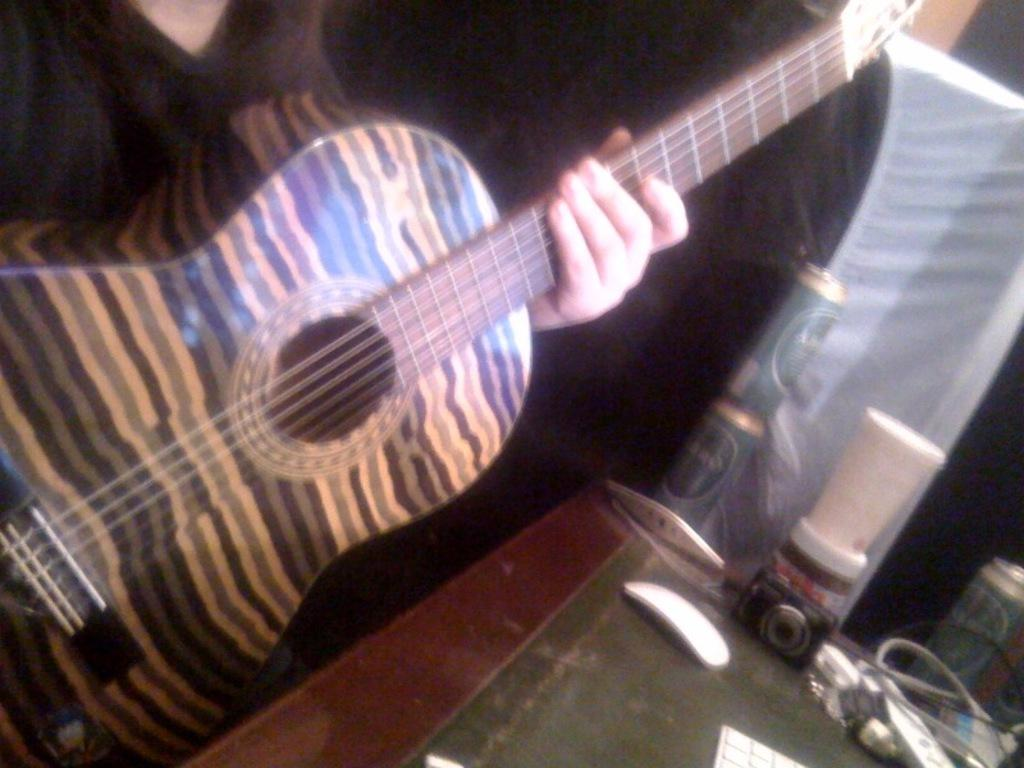What musical instrument is visible in the image? There is a guitar in the image. Where is the guitar positioned in relation to the table? The guitar is in front of a table. What can be found on the table in the image? There are some things placed on the table. What type of bun is being used as a guide for playing the guitar in the image? There is no bun present in the image, nor is there any indication that a bun is being used as a guide for playing the guitar. 